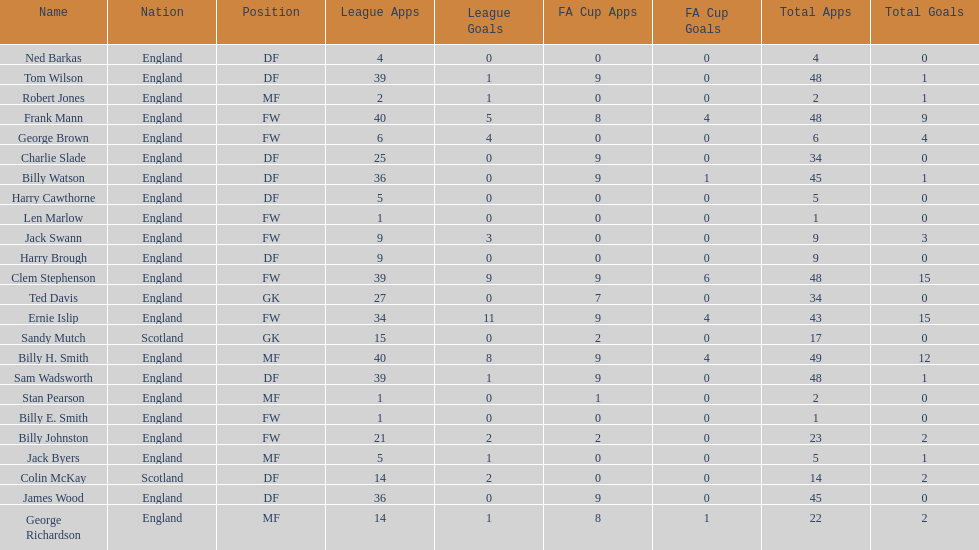What is the last name listed on this chart? James Wood. 